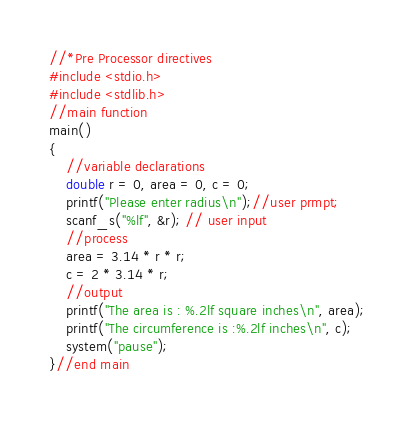<code> <loc_0><loc_0><loc_500><loc_500><_C_>//*Pre Processor directives
#include <stdio.h>
#include <stdlib.h>
//main function
main()
{
	//variable declarations
	double r = 0, area = 0, c = 0;
	printf("Please enter radius\n");//user prmpt;
	scanf_s("%lf", &r); // user input
	//process
	area = 3.14 * r * r;
	c = 2 * 3.14 * r;
	//output
	printf("The area is : %.2lf square inches\n", area);
	printf("The circumference is :%.2lf inches\n", c);
	system("pause");
}//end main
 
</code> 